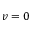Convert formula to latex. <formula><loc_0><loc_0><loc_500><loc_500>v = 0</formula> 